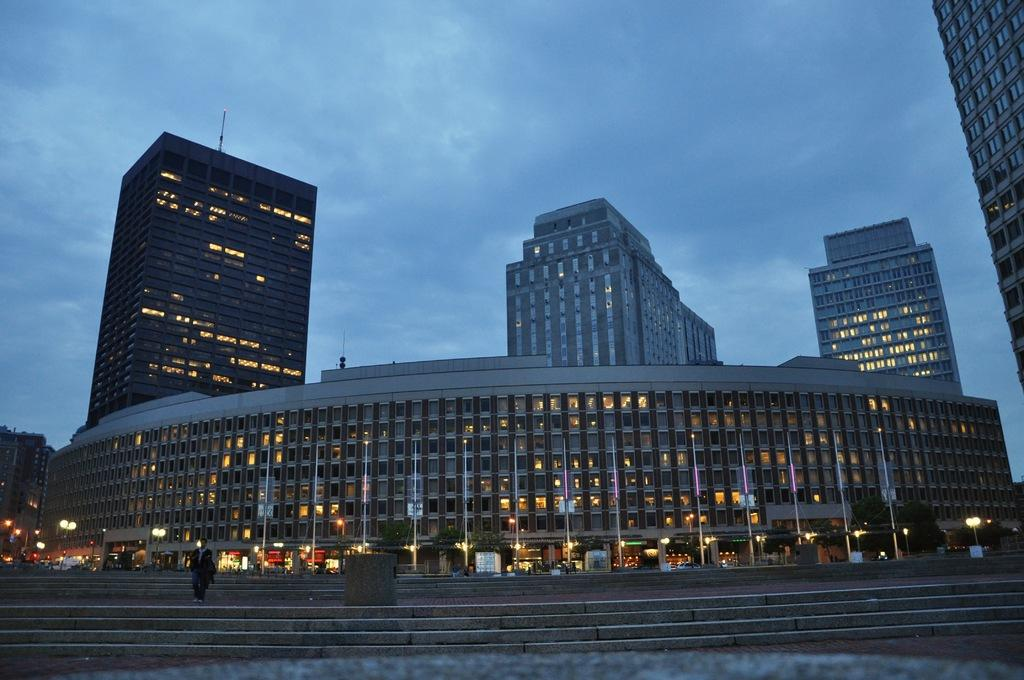What type of structures are present in the image? There are buildings in the image. What is in front of the buildings? There are poles and lamps in front of the buildings. Can you describe the person in the image? There is a person standing on the stairs. What can be seen in the background of the image? The sky is visible in the background of the image. What type of rhythm can be heard coming from the buildings in the image? There is no indication of sound or rhythm in the image, as it only shows visual elements such as buildings, poles, lamps, a person, and the sky. 